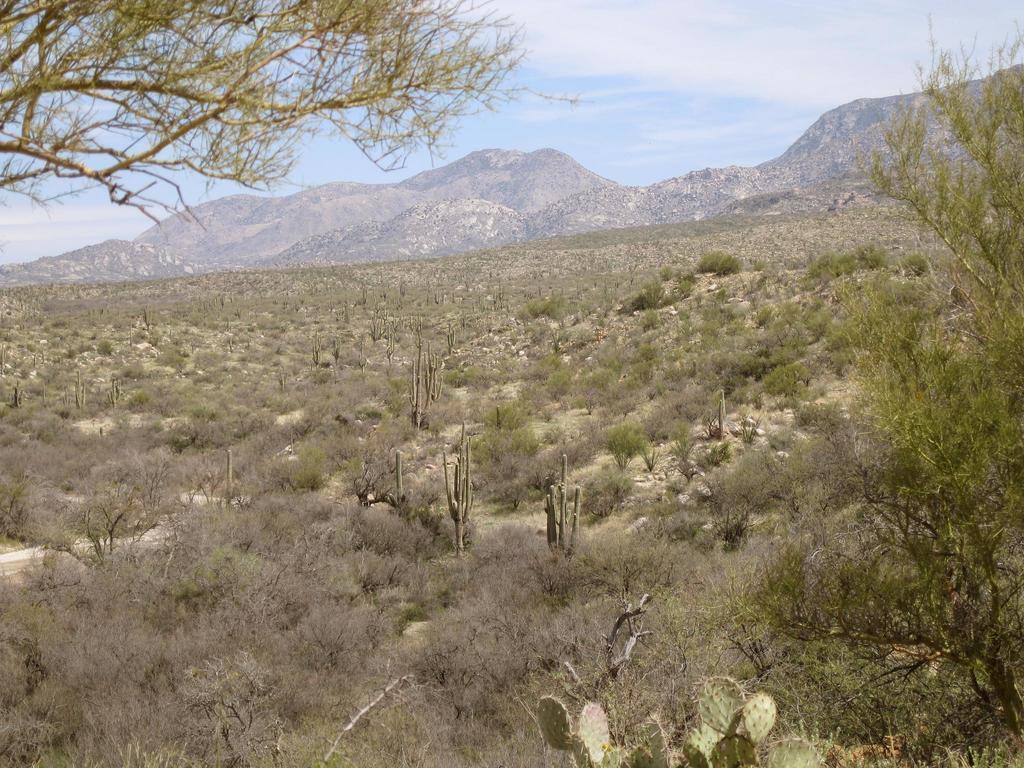Please provide a concise description of this image. This is the picture of a place where we have some trees, plants, rocks and around there are some mountains. 